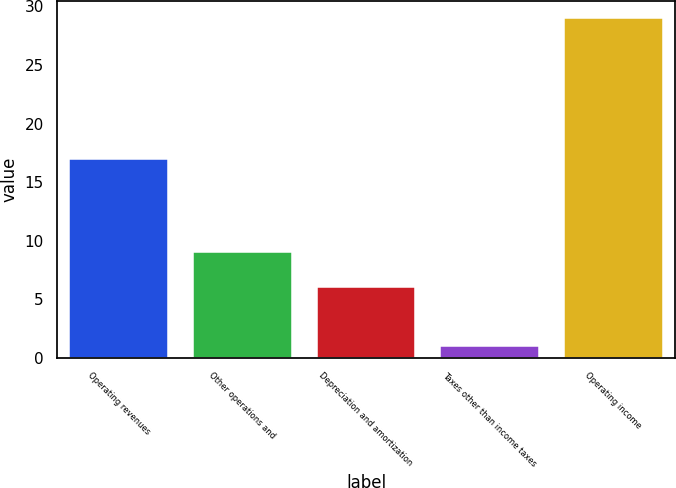Convert chart. <chart><loc_0><loc_0><loc_500><loc_500><bar_chart><fcel>Operating revenues<fcel>Other operations and<fcel>Depreciation and amortization<fcel>Taxes other than income taxes<fcel>Operating income<nl><fcel>17<fcel>9<fcel>6<fcel>1<fcel>29<nl></chart> 